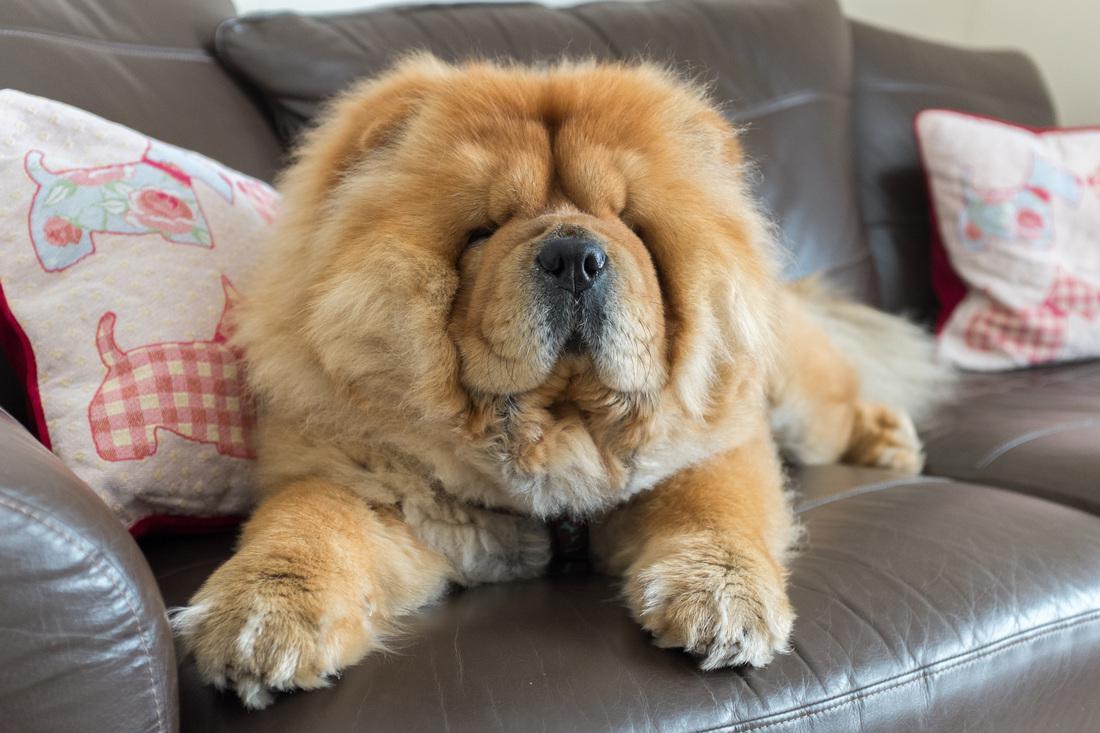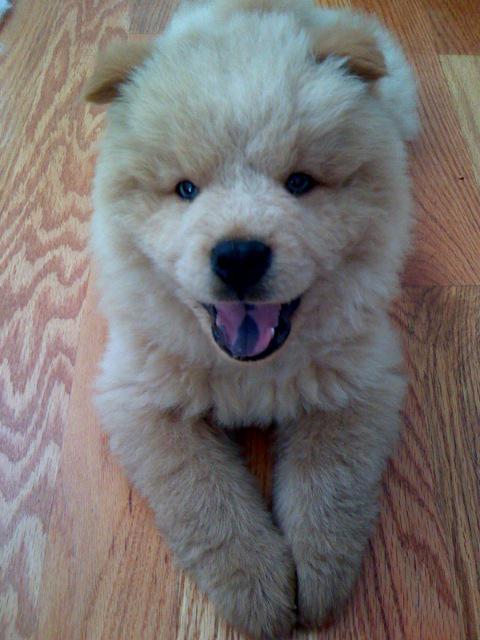The first image is the image on the left, the second image is the image on the right. Evaluate the accuracy of this statement regarding the images: "At least one human is interacting with at least one dog, in one of the images.". Is it true? Answer yes or no. No. 